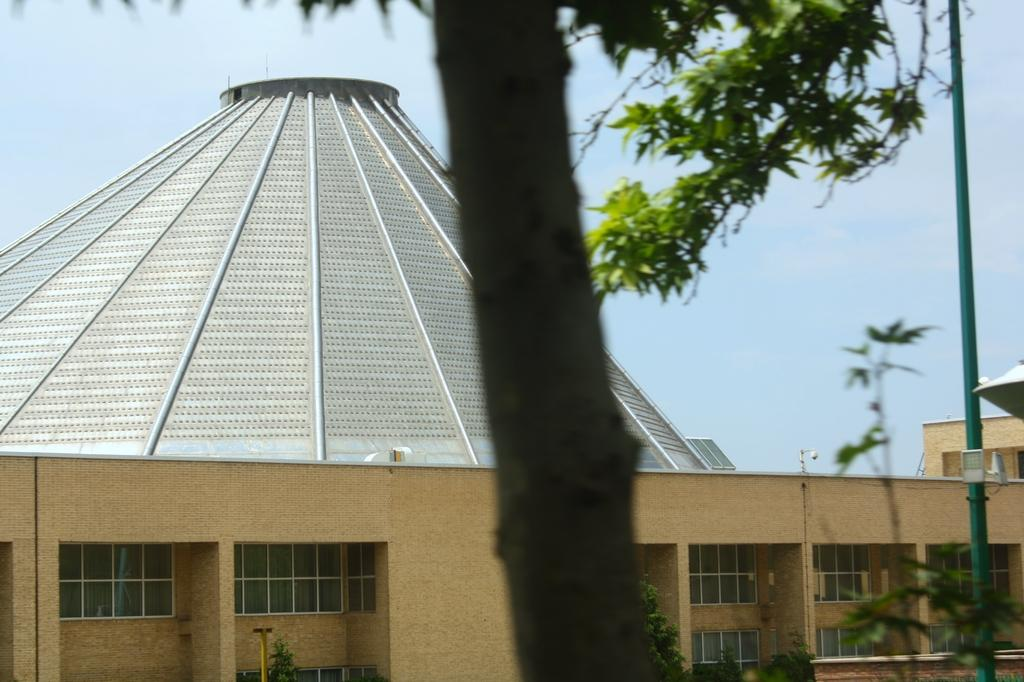What type of structure is present in the picture? There is a building in the picture. What other natural elements can be seen in the picture? There are plants and a tree in the picture. Can you describe the object on the right side of the picture? There is a pole on the right side of the picture. What is the condition of the sky in the picture? The sky is cloudy in the picture. What type of dinner is being served in the picture? There is no dinner present in the picture; it features a building, plants, a tree, a pole, and a cloudy sky. Can you see any steam coming from the building in the picture? There is no steam visible in the picture. 